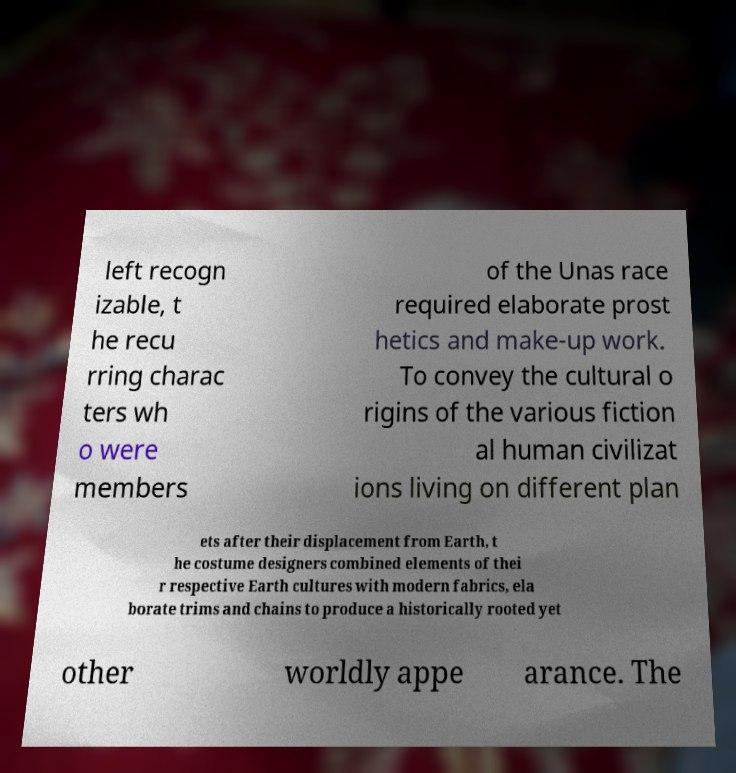I need the written content from this picture converted into text. Can you do that? left recogn izable, t he recu rring charac ters wh o were members of the Unas race required elaborate prost hetics and make-up work. To convey the cultural o rigins of the various fiction al human civilizat ions living on different plan ets after their displacement from Earth, t he costume designers combined elements of thei r respective Earth cultures with modern fabrics, ela borate trims and chains to produce a historically rooted yet other worldly appe arance. The 